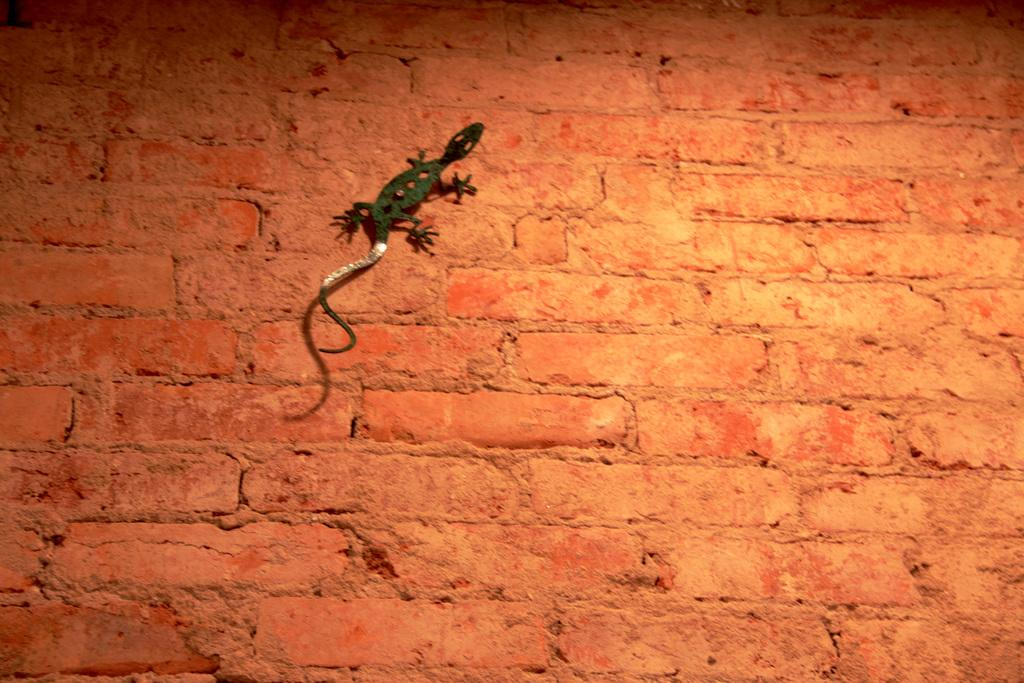What type of animal is in the image? There is a lizard in the image. Where is the lizard located? The lizard is on a wall. What color is the kite that the lizard is holding in the image? There is no kite present in the image, and the lizard is not holding anything. 